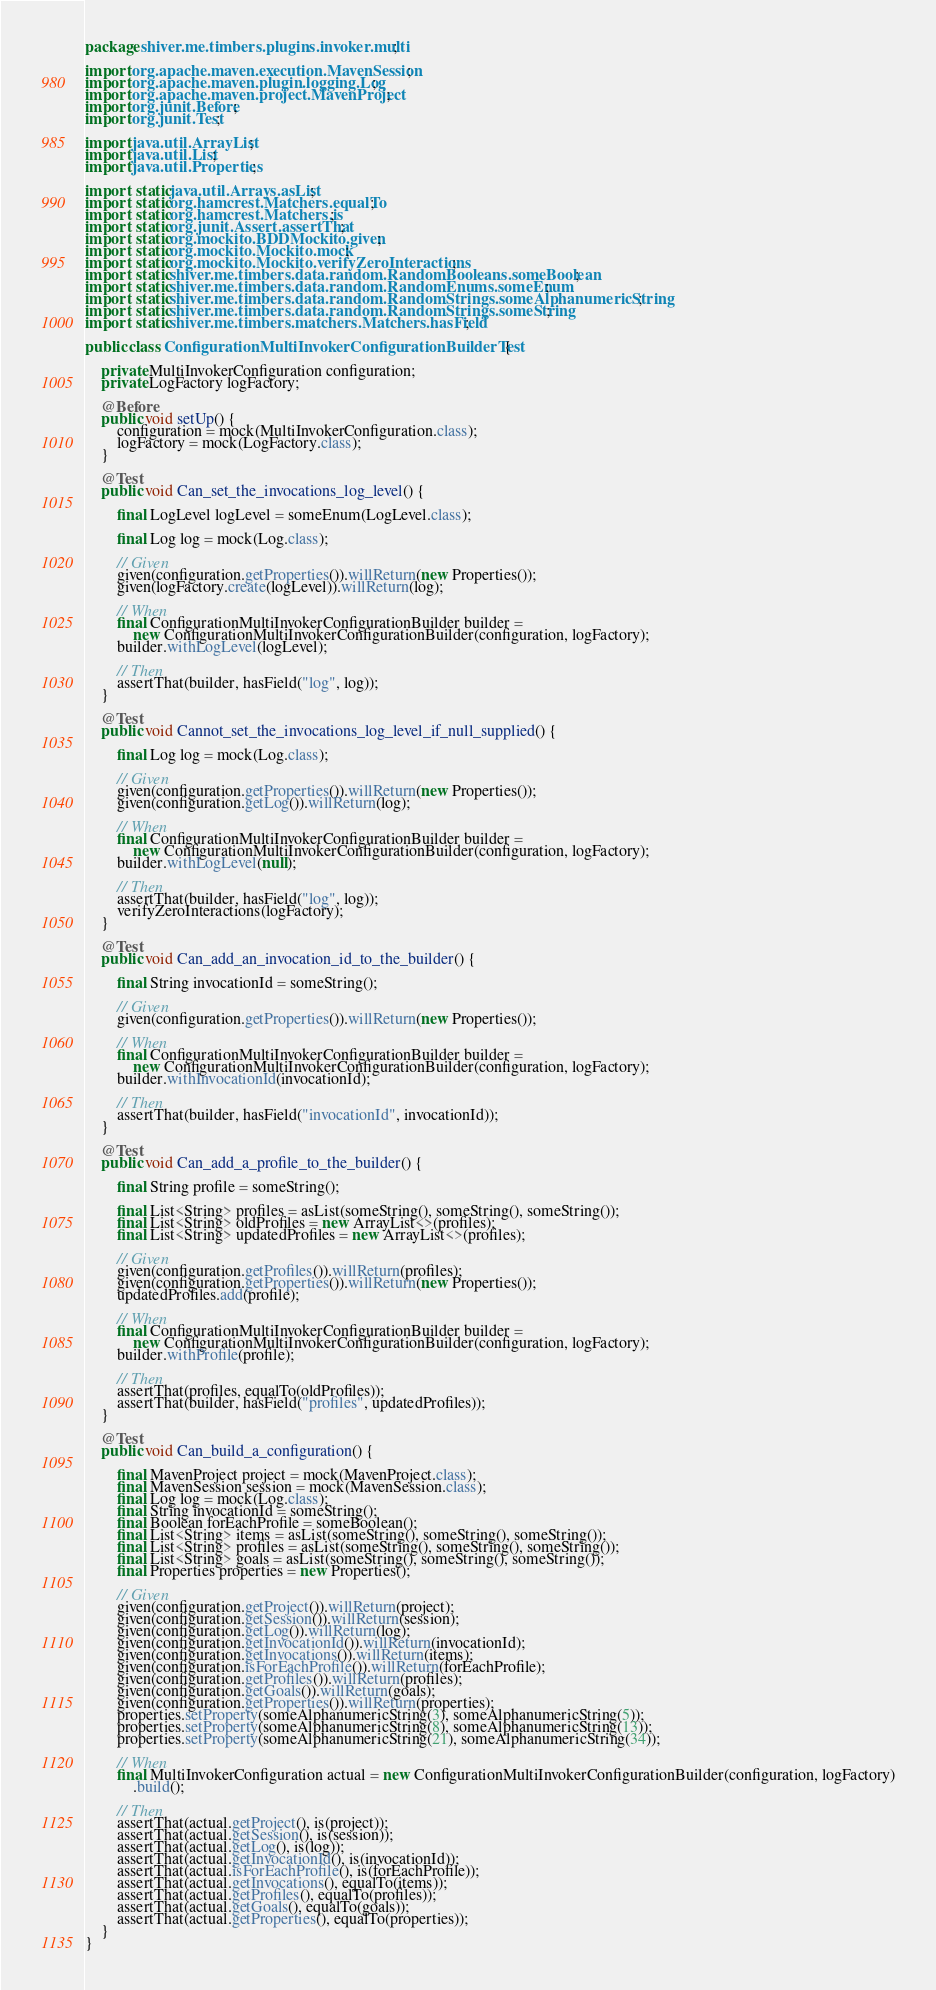<code> <loc_0><loc_0><loc_500><loc_500><_Java_>package shiver.me.timbers.plugins.invoker.multi;

import org.apache.maven.execution.MavenSession;
import org.apache.maven.plugin.logging.Log;
import org.apache.maven.project.MavenProject;
import org.junit.Before;
import org.junit.Test;

import java.util.ArrayList;
import java.util.List;
import java.util.Properties;

import static java.util.Arrays.asList;
import static org.hamcrest.Matchers.equalTo;
import static org.hamcrest.Matchers.is;
import static org.junit.Assert.assertThat;
import static org.mockito.BDDMockito.given;
import static org.mockito.Mockito.mock;
import static org.mockito.Mockito.verifyZeroInteractions;
import static shiver.me.timbers.data.random.RandomBooleans.someBoolean;
import static shiver.me.timbers.data.random.RandomEnums.someEnum;
import static shiver.me.timbers.data.random.RandomStrings.someAlphanumericString;
import static shiver.me.timbers.data.random.RandomStrings.someString;
import static shiver.me.timbers.matchers.Matchers.hasField;

public class ConfigurationMultiInvokerConfigurationBuilderTest {

    private MultiInvokerConfiguration configuration;
    private LogFactory logFactory;

    @Before
    public void setUp() {
        configuration = mock(MultiInvokerConfiguration.class);
        logFactory = mock(LogFactory.class);
    }

    @Test
    public void Can_set_the_invocations_log_level() {

        final LogLevel logLevel = someEnum(LogLevel.class);

        final Log log = mock(Log.class);

        // Given
        given(configuration.getProperties()).willReturn(new Properties());
        given(logFactory.create(logLevel)).willReturn(log);

        // When
        final ConfigurationMultiInvokerConfigurationBuilder builder =
            new ConfigurationMultiInvokerConfigurationBuilder(configuration, logFactory);
        builder.withLogLevel(logLevel);

        // Then
        assertThat(builder, hasField("log", log));
    }

    @Test
    public void Cannot_set_the_invocations_log_level_if_null_supplied() {

        final Log log = mock(Log.class);

        // Given
        given(configuration.getProperties()).willReturn(new Properties());
        given(configuration.getLog()).willReturn(log);

        // When
        final ConfigurationMultiInvokerConfigurationBuilder builder =
            new ConfigurationMultiInvokerConfigurationBuilder(configuration, logFactory);
        builder.withLogLevel(null);

        // Then
        assertThat(builder, hasField("log", log));
        verifyZeroInteractions(logFactory);
    }

    @Test
    public void Can_add_an_invocation_id_to_the_builder() {

        final String invocationId = someString();

        // Given
        given(configuration.getProperties()).willReturn(new Properties());

        // When
        final ConfigurationMultiInvokerConfigurationBuilder builder =
            new ConfigurationMultiInvokerConfigurationBuilder(configuration, logFactory);
        builder.withInvocationId(invocationId);

        // Then
        assertThat(builder, hasField("invocationId", invocationId));
    }

    @Test
    public void Can_add_a_profile_to_the_builder() {

        final String profile = someString();

        final List<String> profiles = asList(someString(), someString(), someString());
        final List<String> oldProfiles = new ArrayList<>(profiles);
        final List<String> updatedProfiles = new ArrayList<>(profiles);

        // Given
        given(configuration.getProfiles()).willReturn(profiles);
        given(configuration.getProperties()).willReturn(new Properties());
        updatedProfiles.add(profile);

        // When
        final ConfigurationMultiInvokerConfigurationBuilder builder =
            new ConfigurationMultiInvokerConfigurationBuilder(configuration, logFactory);
        builder.withProfile(profile);

        // Then
        assertThat(profiles, equalTo(oldProfiles));
        assertThat(builder, hasField("profiles", updatedProfiles));
    }

    @Test
    public void Can_build_a_configuration() {

        final MavenProject project = mock(MavenProject.class);
        final MavenSession session = mock(MavenSession.class);
        final Log log = mock(Log.class);
        final String invocationId = someString();
        final Boolean forEachProfile = someBoolean();
        final List<String> items = asList(someString(), someString(), someString());
        final List<String> profiles = asList(someString(), someString(), someString());
        final List<String> goals = asList(someString(), someString(), someString());
        final Properties properties = new Properties();

        // Given
        given(configuration.getProject()).willReturn(project);
        given(configuration.getSession()).willReturn(session);
        given(configuration.getLog()).willReturn(log);
        given(configuration.getInvocationId()).willReturn(invocationId);
        given(configuration.getInvocations()).willReturn(items);
        given(configuration.isForEachProfile()).willReturn(forEachProfile);
        given(configuration.getProfiles()).willReturn(profiles);
        given(configuration.getGoals()).willReturn(goals);
        given(configuration.getProperties()).willReturn(properties);
        properties.setProperty(someAlphanumericString(3), someAlphanumericString(5));
        properties.setProperty(someAlphanumericString(8), someAlphanumericString(13));
        properties.setProperty(someAlphanumericString(21), someAlphanumericString(34));

        // When
        final MultiInvokerConfiguration actual = new ConfigurationMultiInvokerConfigurationBuilder(configuration, logFactory)
            .build();

        // Then
        assertThat(actual.getProject(), is(project));
        assertThat(actual.getSession(), is(session));
        assertThat(actual.getLog(), is(log));
        assertThat(actual.getInvocationId(), is(invocationId));
        assertThat(actual.isForEachProfile(), is(forEachProfile));
        assertThat(actual.getInvocations(), equalTo(items));
        assertThat(actual.getProfiles(), equalTo(profiles));
        assertThat(actual.getGoals(), equalTo(goals));
        assertThat(actual.getProperties(), equalTo(properties));
    }
}</code> 